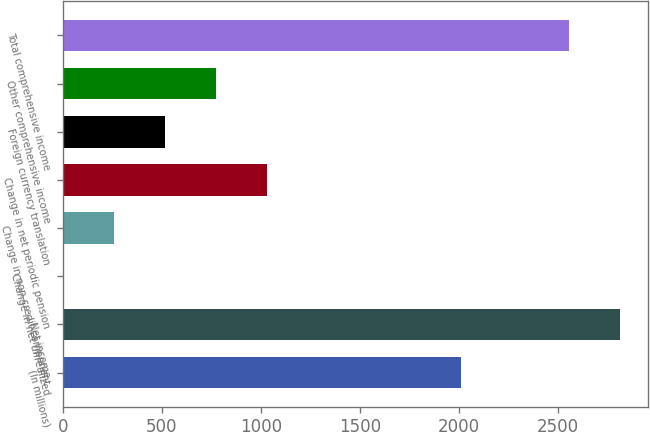Convert chart to OTSL. <chart><loc_0><loc_0><loc_500><loc_500><bar_chart><fcel>(In millions)<fcel>Net income<fcel>Change in net unrealized<fcel>Change in non-credit component<fcel>Change in net periodic pension<fcel>Foreign currency translation<fcel>Other comprehensive income<fcel>Total comprehensive income<nl><fcel>2014<fcel>2815.01<fcel>3.6<fcel>260.21<fcel>1030.04<fcel>516.82<fcel>773.43<fcel>2558.4<nl></chart> 